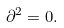<formula> <loc_0><loc_0><loc_500><loc_500>\partial ^ { 2 } = 0 .</formula> 